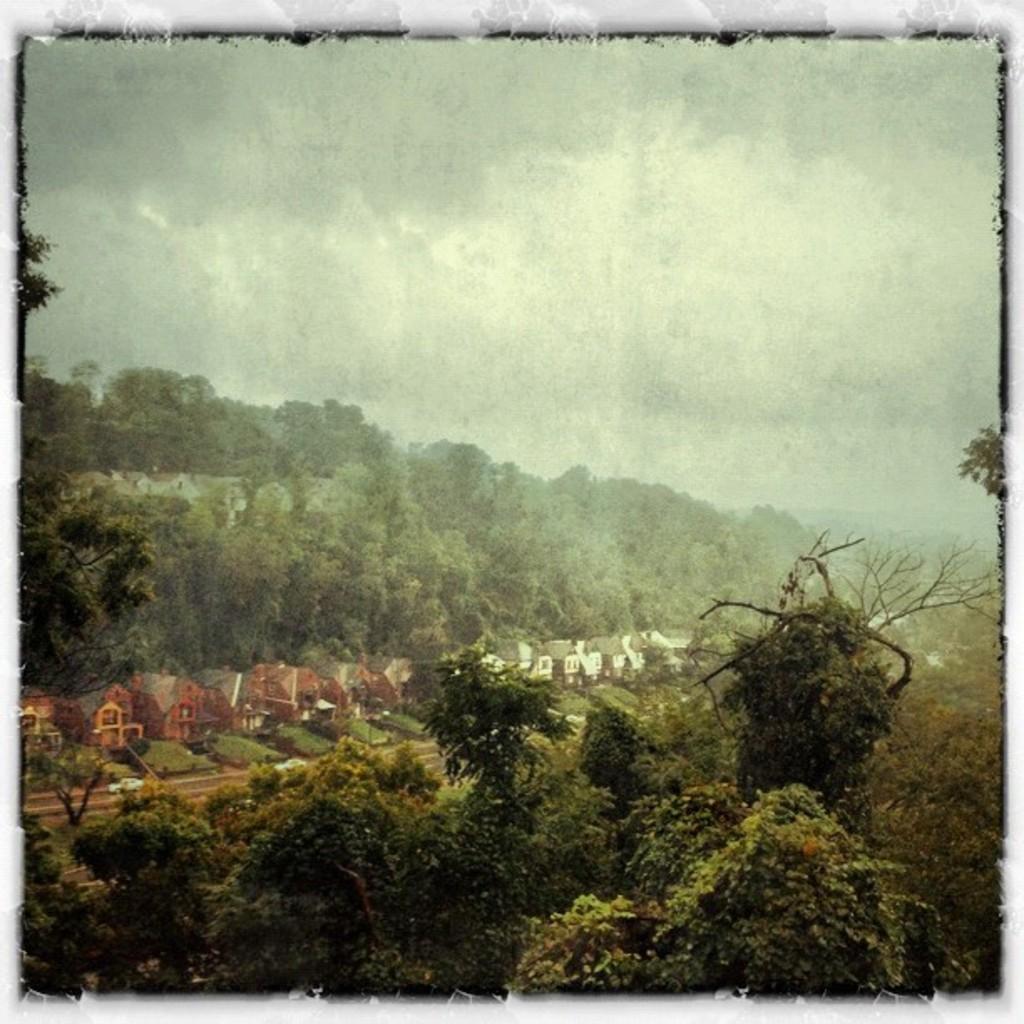Can you describe this image briefly? In this image we can see many houses and also trees. There is a cloudy sky and the image has borders. 